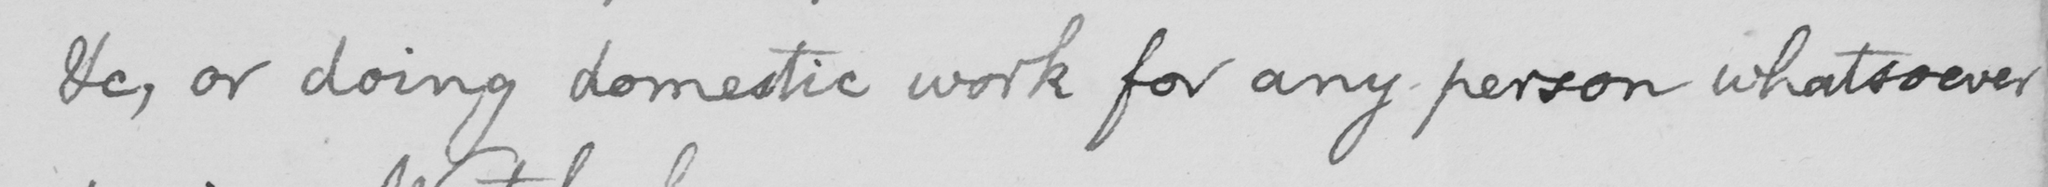What is written in this line of handwriting? &c or doing domestic work for any person whatsoever 